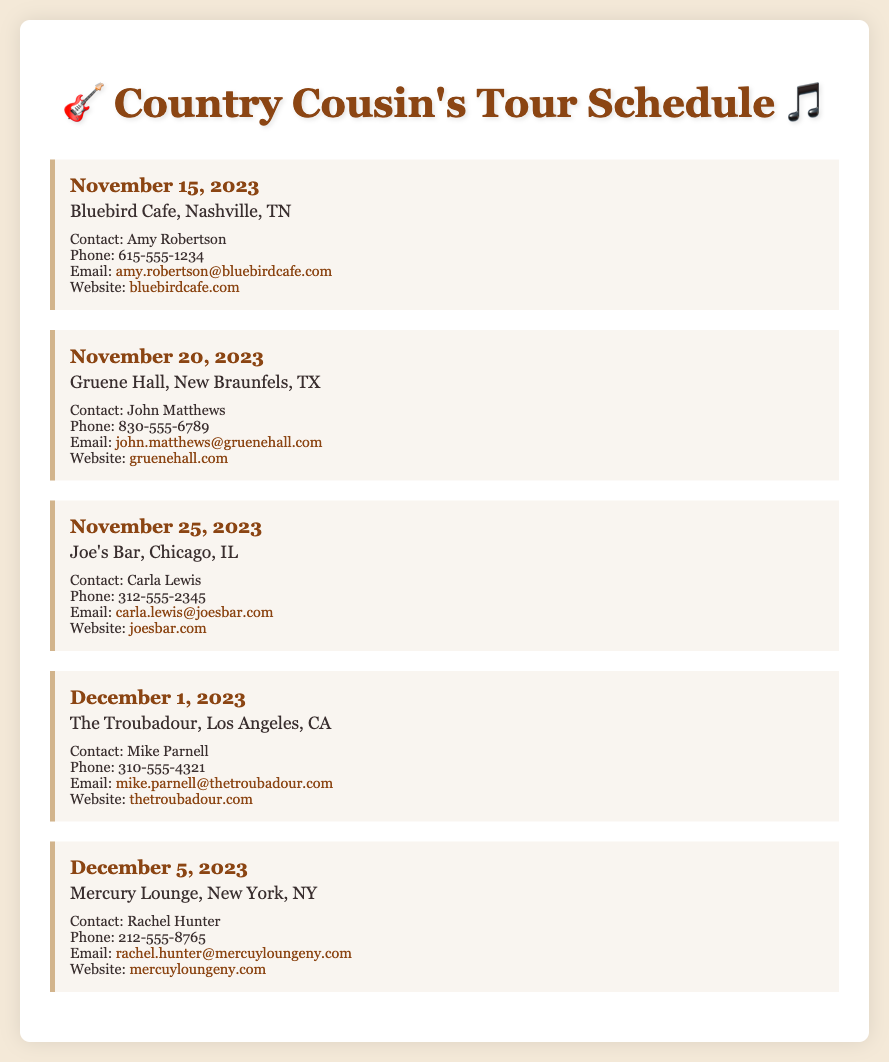What is the date of the performance at Bluebird Cafe? The performance at Bluebird Cafe is scheduled for November 15, 2023.
Answer: November 15, 2023 Who is the contact person for Joe's Bar in Chicago? The contact person for Joe's Bar is Carla Lewis.
Answer: Carla Lewis What city is Gruene Hall located in? Gruene Hall is located in New Braunfels, TX.
Answer: New Braunfels, TX How many days are there between the performances at The Troubadour and Mercury Lounge? The Troubadour performance is on December 1, 2023, and Mercury Lounge performance on December 5, 2023, making it 4 days apart.
Answer: 4 days What is the website for the venue in New York? The website for Mercury Lounge in New York is provided in the document.
Answer: mercuyloungeny.com 